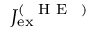<formula> <loc_0><loc_0><loc_500><loc_500>J _ { e x } ^ { ( \mathrm { H E } ) }</formula> 